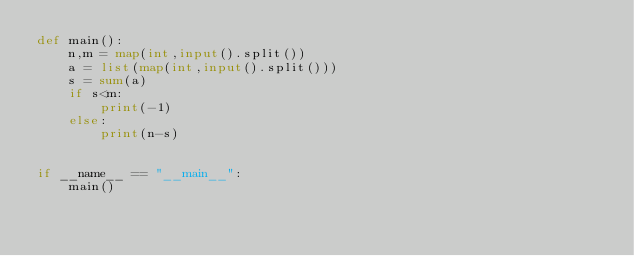<code> <loc_0><loc_0><loc_500><loc_500><_Python_>def main():
    n,m = map(int,input().split())
    a = list(map(int,input().split()))
    s = sum(a)
    if s<m:
        print(-1)
    else:
        print(n-s)


if __name__ == "__main__":
    main()</code> 